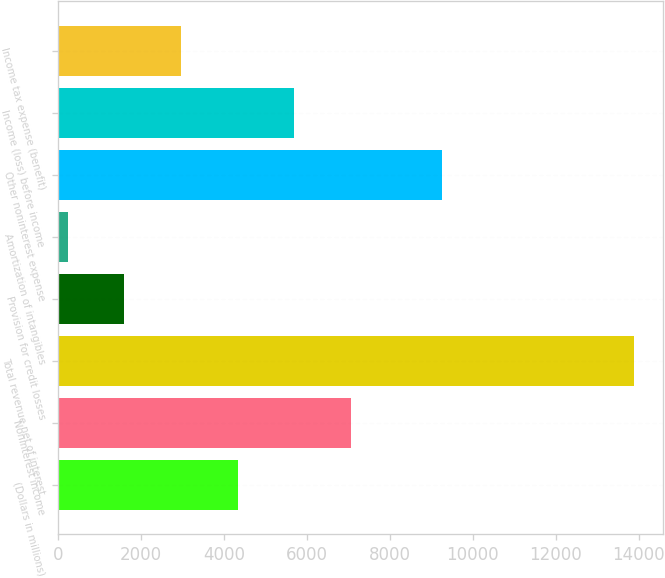<chart> <loc_0><loc_0><loc_500><loc_500><bar_chart><fcel>(Dollars in millions)<fcel>Noninterest income<fcel>Total revenue net of interest<fcel>Provision for credit losses<fcel>Amortization of intangibles<fcel>Other noninterest expense<fcel>Income (loss) before income<fcel>Income tax expense (benefit)<nl><fcel>4333.6<fcel>7064<fcel>13890<fcel>1603.2<fcel>238<fcel>9263<fcel>5698.8<fcel>2968.4<nl></chart> 